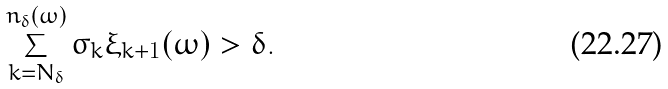<formula> <loc_0><loc_0><loc_500><loc_500>\sum _ { k = N _ { \delta } } ^ { n _ { \delta } ( \omega ) } \sigma _ { k } \xi _ { k + 1 } ( \omega ) > \delta .</formula> 